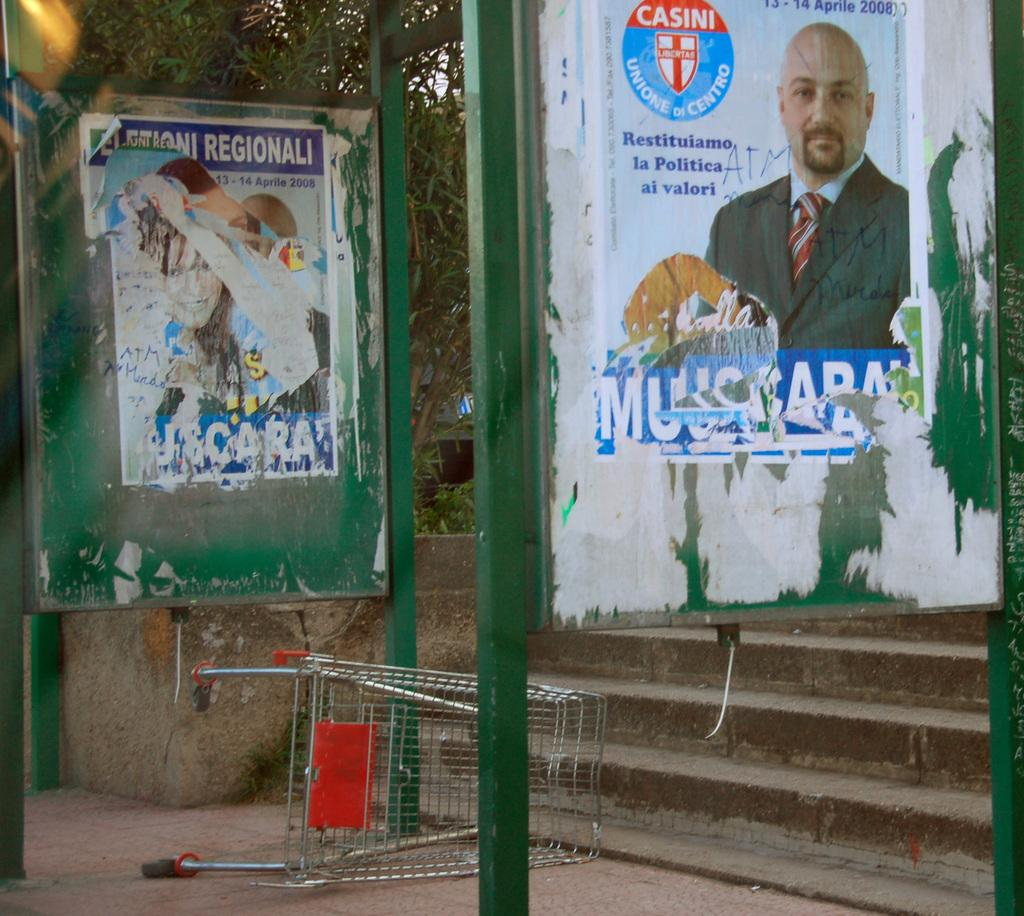<image>
Give a short and clear explanation of the subsequent image. A sidewalk and stairs are seen under a poster with the Casini logo on it. 